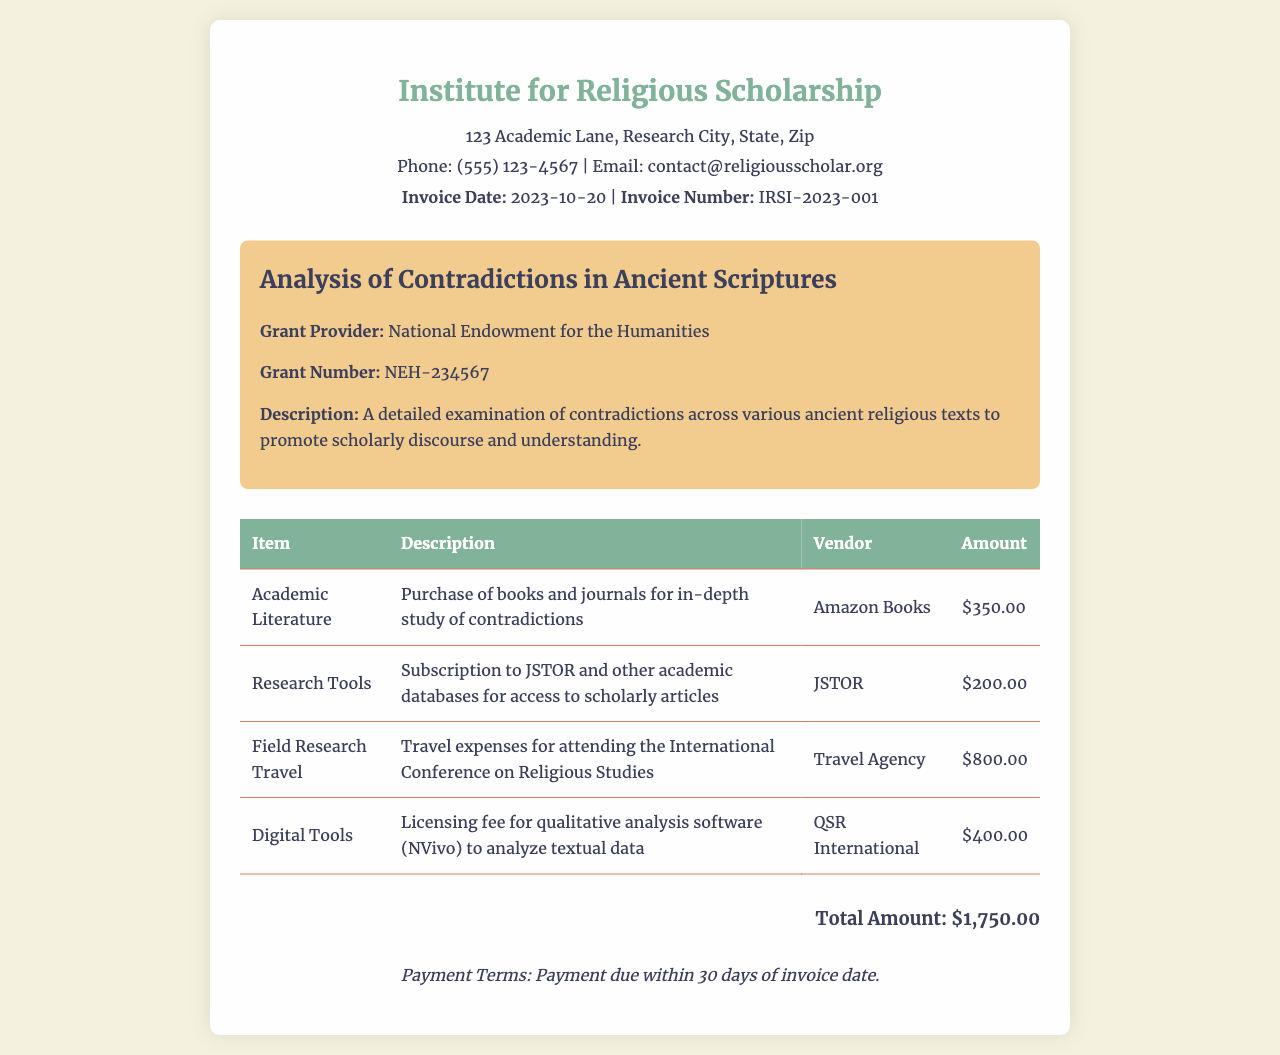What is the total amount? The total amount is explicitly stated at the end of the invoice as $1,750.00.
Answer: $1,750.00 What is the invoice date? The invoice date is mentioned in the header, indicating when the invoice was issued as 2023-10-20.
Answer: 2023-10-20 Who is the grant provider? The grant provider is mentioned in the project details section, stating it is the National Endowment for the Humanities.
Answer: National Endowment for the Humanities What is the description of the project? The description of the project is provided in the project details section, explaining the focus of the research.
Answer: A detailed examination of contradictions across various ancient religious texts to promote scholarly discourse and understanding How much was spent on academic literature? The amount for academic literature is detailed in the table, specifying the expense incurred for this category.
Answer: $350.00 How many items are listed in the invoice? The number of items can be counted in the table listing expenses, including literature, tools, travel, and digital tools.
Answer: 4 What is the payment term stated in the document? The payment term is included in the footer of the invoice, specifying the timeframe for payment obligations.
Answer: Payment due within 30 days of invoice date What is the vendor for the digital tools? The vendor for digital tools is clearly specified in the table for the licensing fee of the software.
Answer: QSR International How much was spent on field research travel? The amount for field research travel is listed explicitly in the table of expenses for this category.
Answer: $800.00 